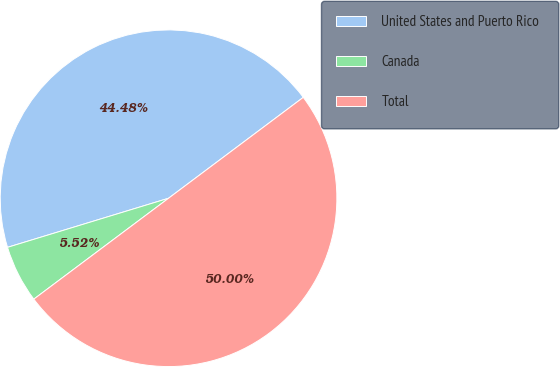Convert chart to OTSL. <chart><loc_0><loc_0><loc_500><loc_500><pie_chart><fcel>United States and Puerto Rico<fcel>Canada<fcel>Total<nl><fcel>44.48%<fcel>5.52%<fcel>50.0%<nl></chart> 